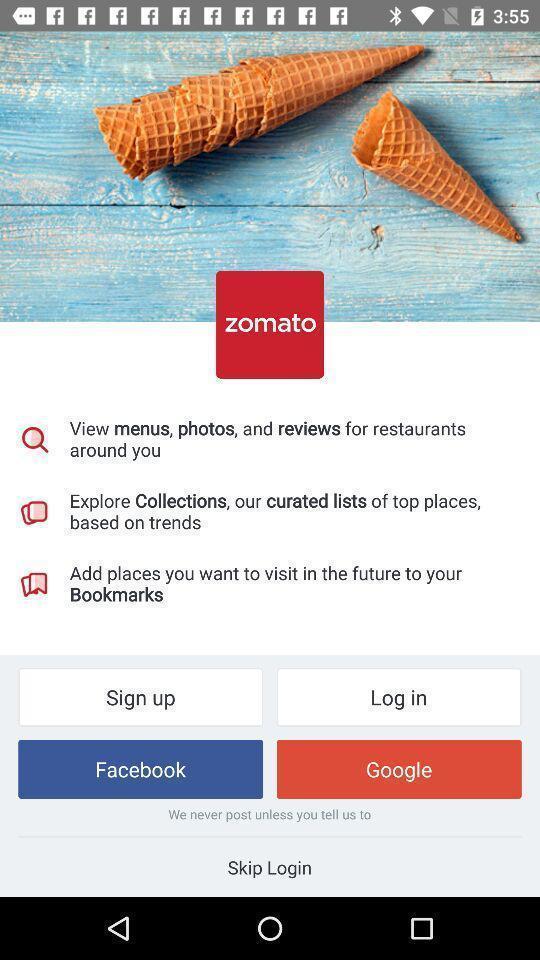Describe this image in words. Screen page of a food application. 